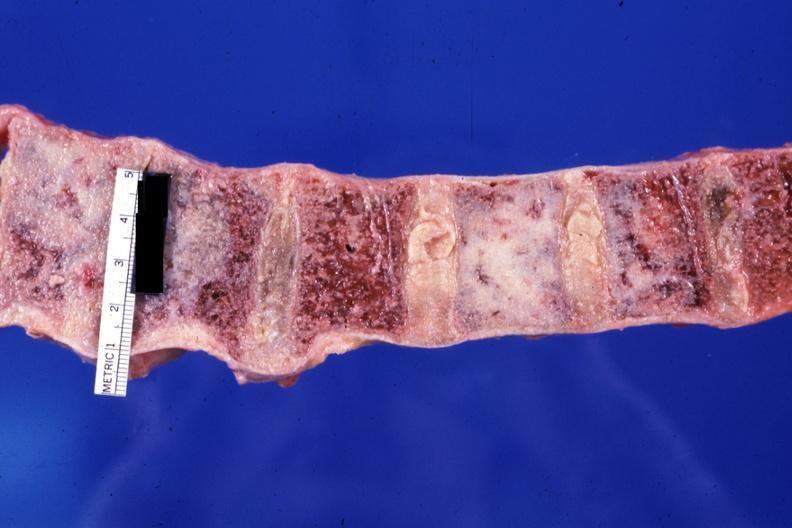s joints present?
Answer the question using a single word or phrase. Yes 